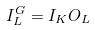<formula> <loc_0><loc_0><loc_500><loc_500>I _ { L } ^ { G } = I _ { K } O _ { L }</formula> 